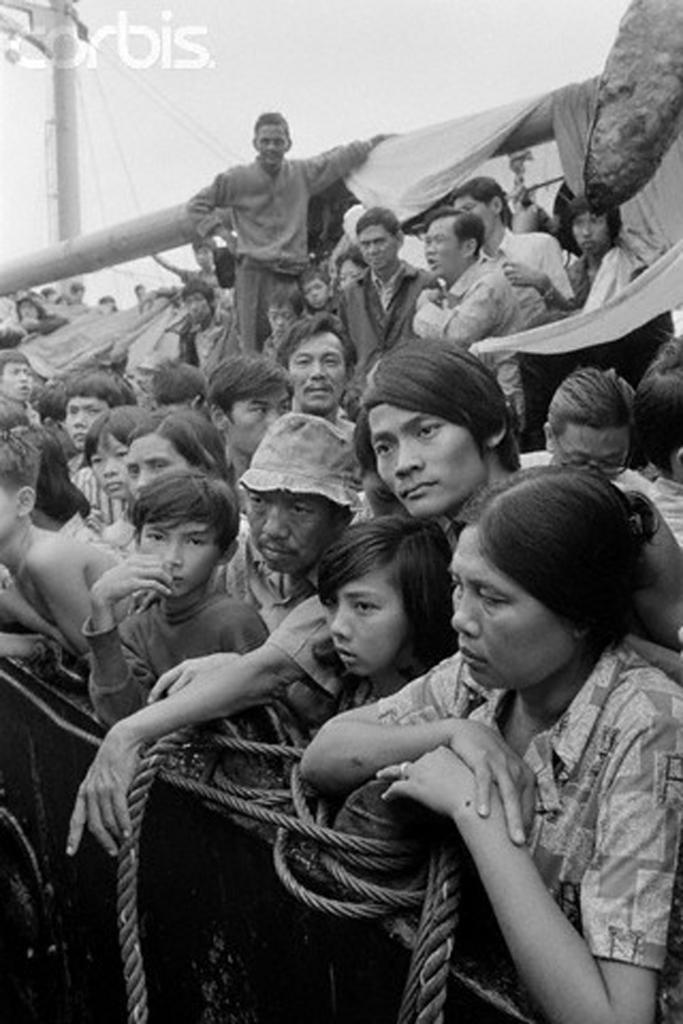Please provide a concise description of this image. In this image I can see group of people, some are sitting and some are standing. I can also see few ropes, background I can see a light pole and the image is in black and white. 